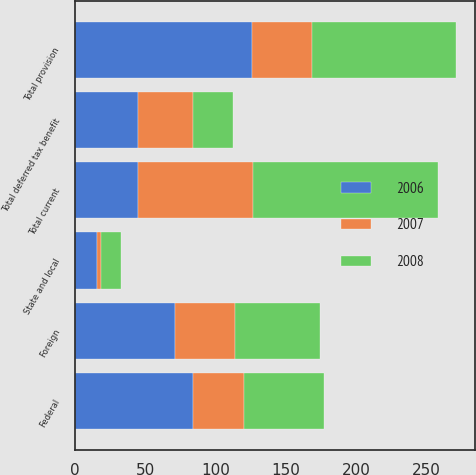Convert chart. <chart><loc_0><loc_0><loc_500><loc_500><stacked_bar_chart><ecel><fcel>Federal<fcel>State and local<fcel>Foreign<fcel>Total current<fcel>Total deferred tax benefit<fcel>Total provision<nl><fcel>2007<fcel>36.7<fcel>2.6<fcel>42.6<fcel>81.9<fcel>39.5<fcel>42.4<nl><fcel>2008<fcel>56.8<fcel>14.2<fcel>60.5<fcel>131.5<fcel>28.5<fcel>103<nl><fcel>2006<fcel>83.7<fcel>16<fcel>71<fcel>44.7<fcel>44.7<fcel>126<nl></chart> 